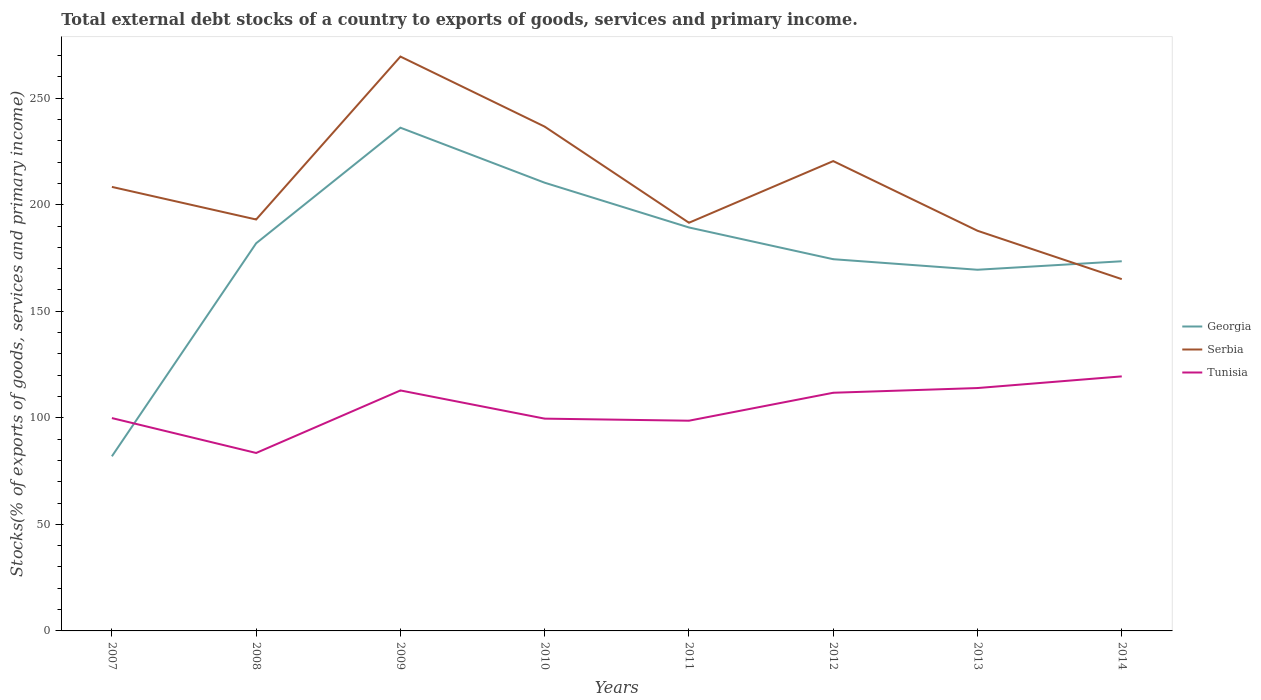How many different coloured lines are there?
Provide a succinct answer. 3. Across all years, what is the maximum total debt stocks in Georgia?
Ensure brevity in your answer.  81.94. What is the total total debt stocks in Georgia in the graph?
Your answer should be compact. 12.43. What is the difference between the highest and the second highest total debt stocks in Tunisia?
Provide a short and direct response. 35.95. Is the total debt stocks in Georgia strictly greater than the total debt stocks in Tunisia over the years?
Keep it short and to the point. No. How many years are there in the graph?
Offer a very short reply. 8. What is the difference between two consecutive major ticks on the Y-axis?
Offer a terse response. 50. Are the values on the major ticks of Y-axis written in scientific E-notation?
Provide a succinct answer. No. Does the graph contain grids?
Your response must be concise. No. Where does the legend appear in the graph?
Your answer should be very brief. Center right. What is the title of the graph?
Your response must be concise. Total external debt stocks of a country to exports of goods, services and primary income. Does "Djibouti" appear as one of the legend labels in the graph?
Give a very brief answer. No. What is the label or title of the X-axis?
Offer a very short reply. Years. What is the label or title of the Y-axis?
Offer a very short reply. Stocks(% of exports of goods, services and primary income). What is the Stocks(% of exports of goods, services and primary income) of Georgia in 2007?
Provide a short and direct response. 81.94. What is the Stocks(% of exports of goods, services and primary income) in Serbia in 2007?
Ensure brevity in your answer.  208.38. What is the Stocks(% of exports of goods, services and primary income) in Tunisia in 2007?
Offer a very short reply. 99.89. What is the Stocks(% of exports of goods, services and primary income) in Georgia in 2008?
Give a very brief answer. 181.93. What is the Stocks(% of exports of goods, services and primary income) of Serbia in 2008?
Offer a very short reply. 193.09. What is the Stocks(% of exports of goods, services and primary income) of Tunisia in 2008?
Ensure brevity in your answer.  83.51. What is the Stocks(% of exports of goods, services and primary income) of Georgia in 2009?
Offer a terse response. 236.17. What is the Stocks(% of exports of goods, services and primary income) of Serbia in 2009?
Provide a short and direct response. 269.55. What is the Stocks(% of exports of goods, services and primary income) in Tunisia in 2009?
Ensure brevity in your answer.  112.86. What is the Stocks(% of exports of goods, services and primary income) of Georgia in 2010?
Your answer should be compact. 210.35. What is the Stocks(% of exports of goods, services and primary income) of Serbia in 2010?
Offer a terse response. 236.67. What is the Stocks(% of exports of goods, services and primary income) of Tunisia in 2010?
Your answer should be compact. 99.63. What is the Stocks(% of exports of goods, services and primary income) of Georgia in 2011?
Your answer should be very brief. 189.34. What is the Stocks(% of exports of goods, services and primary income) in Serbia in 2011?
Your response must be concise. 191.56. What is the Stocks(% of exports of goods, services and primary income) of Tunisia in 2011?
Offer a terse response. 98.66. What is the Stocks(% of exports of goods, services and primary income) of Georgia in 2012?
Your response must be concise. 174.45. What is the Stocks(% of exports of goods, services and primary income) of Serbia in 2012?
Offer a very short reply. 220.5. What is the Stocks(% of exports of goods, services and primary income) of Tunisia in 2012?
Offer a very short reply. 111.77. What is the Stocks(% of exports of goods, services and primary income) in Georgia in 2013?
Your response must be concise. 169.5. What is the Stocks(% of exports of goods, services and primary income) in Serbia in 2013?
Make the answer very short. 187.8. What is the Stocks(% of exports of goods, services and primary income) in Tunisia in 2013?
Offer a very short reply. 113.98. What is the Stocks(% of exports of goods, services and primary income) in Georgia in 2014?
Make the answer very short. 173.49. What is the Stocks(% of exports of goods, services and primary income) in Serbia in 2014?
Keep it short and to the point. 165.09. What is the Stocks(% of exports of goods, services and primary income) of Tunisia in 2014?
Provide a succinct answer. 119.46. Across all years, what is the maximum Stocks(% of exports of goods, services and primary income) of Georgia?
Make the answer very short. 236.17. Across all years, what is the maximum Stocks(% of exports of goods, services and primary income) of Serbia?
Your answer should be very brief. 269.55. Across all years, what is the maximum Stocks(% of exports of goods, services and primary income) of Tunisia?
Give a very brief answer. 119.46. Across all years, what is the minimum Stocks(% of exports of goods, services and primary income) in Georgia?
Your answer should be very brief. 81.94. Across all years, what is the minimum Stocks(% of exports of goods, services and primary income) in Serbia?
Offer a very short reply. 165.09. Across all years, what is the minimum Stocks(% of exports of goods, services and primary income) in Tunisia?
Your answer should be very brief. 83.51. What is the total Stocks(% of exports of goods, services and primary income) in Georgia in the graph?
Provide a succinct answer. 1417.17. What is the total Stocks(% of exports of goods, services and primary income) of Serbia in the graph?
Your answer should be compact. 1672.65. What is the total Stocks(% of exports of goods, services and primary income) in Tunisia in the graph?
Make the answer very short. 839.78. What is the difference between the Stocks(% of exports of goods, services and primary income) in Georgia in 2007 and that in 2008?
Your answer should be compact. -99.99. What is the difference between the Stocks(% of exports of goods, services and primary income) in Serbia in 2007 and that in 2008?
Offer a terse response. 15.29. What is the difference between the Stocks(% of exports of goods, services and primary income) in Tunisia in 2007 and that in 2008?
Keep it short and to the point. 16.38. What is the difference between the Stocks(% of exports of goods, services and primary income) of Georgia in 2007 and that in 2009?
Offer a very short reply. -154.23. What is the difference between the Stocks(% of exports of goods, services and primary income) of Serbia in 2007 and that in 2009?
Offer a very short reply. -61.17. What is the difference between the Stocks(% of exports of goods, services and primary income) of Tunisia in 2007 and that in 2009?
Ensure brevity in your answer.  -12.97. What is the difference between the Stocks(% of exports of goods, services and primary income) of Georgia in 2007 and that in 2010?
Provide a succinct answer. -128.41. What is the difference between the Stocks(% of exports of goods, services and primary income) in Serbia in 2007 and that in 2010?
Ensure brevity in your answer.  -28.29. What is the difference between the Stocks(% of exports of goods, services and primary income) of Tunisia in 2007 and that in 2010?
Give a very brief answer. 0.26. What is the difference between the Stocks(% of exports of goods, services and primary income) in Georgia in 2007 and that in 2011?
Ensure brevity in your answer.  -107.4. What is the difference between the Stocks(% of exports of goods, services and primary income) in Serbia in 2007 and that in 2011?
Keep it short and to the point. 16.82. What is the difference between the Stocks(% of exports of goods, services and primary income) of Tunisia in 2007 and that in 2011?
Offer a very short reply. 1.24. What is the difference between the Stocks(% of exports of goods, services and primary income) of Georgia in 2007 and that in 2012?
Offer a very short reply. -92.51. What is the difference between the Stocks(% of exports of goods, services and primary income) of Serbia in 2007 and that in 2012?
Ensure brevity in your answer.  -12.11. What is the difference between the Stocks(% of exports of goods, services and primary income) of Tunisia in 2007 and that in 2012?
Your answer should be compact. -11.88. What is the difference between the Stocks(% of exports of goods, services and primary income) of Georgia in 2007 and that in 2013?
Give a very brief answer. -87.56. What is the difference between the Stocks(% of exports of goods, services and primary income) in Serbia in 2007 and that in 2013?
Provide a short and direct response. 20.59. What is the difference between the Stocks(% of exports of goods, services and primary income) in Tunisia in 2007 and that in 2013?
Your response must be concise. -14.09. What is the difference between the Stocks(% of exports of goods, services and primary income) of Georgia in 2007 and that in 2014?
Keep it short and to the point. -91.55. What is the difference between the Stocks(% of exports of goods, services and primary income) of Serbia in 2007 and that in 2014?
Your response must be concise. 43.29. What is the difference between the Stocks(% of exports of goods, services and primary income) in Tunisia in 2007 and that in 2014?
Ensure brevity in your answer.  -19.57. What is the difference between the Stocks(% of exports of goods, services and primary income) of Georgia in 2008 and that in 2009?
Ensure brevity in your answer.  -54.24. What is the difference between the Stocks(% of exports of goods, services and primary income) in Serbia in 2008 and that in 2009?
Provide a succinct answer. -76.47. What is the difference between the Stocks(% of exports of goods, services and primary income) of Tunisia in 2008 and that in 2009?
Your answer should be compact. -29.34. What is the difference between the Stocks(% of exports of goods, services and primary income) in Georgia in 2008 and that in 2010?
Provide a succinct answer. -28.42. What is the difference between the Stocks(% of exports of goods, services and primary income) of Serbia in 2008 and that in 2010?
Keep it short and to the point. -43.58. What is the difference between the Stocks(% of exports of goods, services and primary income) in Tunisia in 2008 and that in 2010?
Give a very brief answer. -16.11. What is the difference between the Stocks(% of exports of goods, services and primary income) in Georgia in 2008 and that in 2011?
Provide a succinct answer. -7.41. What is the difference between the Stocks(% of exports of goods, services and primary income) of Serbia in 2008 and that in 2011?
Ensure brevity in your answer.  1.53. What is the difference between the Stocks(% of exports of goods, services and primary income) of Tunisia in 2008 and that in 2011?
Provide a short and direct response. -15.14. What is the difference between the Stocks(% of exports of goods, services and primary income) of Georgia in 2008 and that in 2012?
Make the answer very short. 7.48. What is the difference between the Stocks(% of exports of goods, services and primary income) in Serbia in 2008 and that in 2012?
Offer a terse response. -27.41. What is the difference between the Stocks(% of exports of goods, services and primary income) of Tunisia in 2008 and that in 2012?
Give a very brief answer. -28.26. What is the difference between the Stocks(% of exports of goods, services and primary income) of Georgia in 2008 and that in 2013?
Ensure brevity in your answer.  12.43. What is the difference between the Stocks(% of exports of goods, services and primary income) in Serbia in 2008 and that in 2013?
Offer a terse response. 5.29. What is the difference between the Stocks(% of exports of goods, services and primary income) of Tunisia in 2008 and that in 2013?
Offer a terse response. -30.47. What is the difference between the Stocks(% of exports of goods, services and primary income) in Georgia in 2008 and that in 2014?
Ensure brevity in your answer.  8.44. What is the difference between the Stocks(% of exports of goods, services and primary income) of Serbia in 2008 and that in 2014?
Give a very brief answer. 27.99. What is the difference between the Stocks(% of exports of goods, services and primary income) of Tunisia in 2008 and that in 2014?
Give a very brief answer. -35.95. What is the difference between the Stocks(% of exports of goods, services and primary income) in Georgia in 2009 and that in 2010?
Offer a terse response. 25.82. What is the difference between the Stocks(% of exports of goods, services and primary income) in Serbia in 2009 and that in 2010?
Offer a very short reply. 32.89. What is the difference between the Stocks(% of exports of goods, services and primary income) of Tunisia in 2009 and that in 2010?
Provide a short and direct response. 13.23. What is the difference between the Stocks(% of exports of goods, services and primary income) of Georgia in 2009 and that in 2011?
Make the answer very short. 46.83. What is the difference between the Stocks(% of exports of goods, services and primary income) in Serbia in 2009 and that in 2011?
Give a very brief answer. 77.99. What is the difference between the Stocks(% of exports of goods, services and primary income) in Tunisia in 2009 and that in 2011?
Give a very brief answer. 14.2. What is the difference between the Stocks(% of exports of goods, services and primary income) in Georgia in 2009 and that in 2012?
Your answer should be very brief. 61.72. What is the difference between the Stocks(% of exports of goods, services and primary income) in Serbia in 2009 and that in 2012?
Provide a succinct answer. 49.06. What is the difference between the Stocks(% of exports of goods, services and primary income) of Tunisia in 2009 and that in 2012?
Keep it short and to the point. 1.09. What is the difference between the Stocks(% of exports of goods, services and primary income) in Georgia in 2009 and that in 2013?
Offer a terse response. 66.67. What is the difference between the Stocks(% of exports of goods, services and primary income) of Serbia in 2009 and that in 2013?
Your answer should be compact. 81.76. What is the difference between the Stocks(% of exports of goods, services and primary income) in Tunisia in 2009 and that in 2013?
Offer a terse response. -1.13. What is the difference between the Stocks(% of exports of goods, services and primary income) in Georgia in 2009 and that in 2014?
Offer a very short reply. 62.68. What is the difference between the Stocks(% of exports of goods, services and primary income) in Serbia in 2009 and that in 2014?
Make the answer very short. 104.46. What is the difference between the Stocks(% of exports of goods, services and primary income) in Tunisia in 2009 and that in 2014?
Provide a succinct answer. -6.6. What is the difference between the Stocks(% of exports of goods, services and primary income) in Georgia in 2010 and that in 2011?
Offer a very short reply. 21.01. What is the difference between the Stocks(% of exports of goods, services and primary income) in Serbia in 2010 and that in 2011?
Provide a succinct answer. 45.11. What is the difference between the Stocks(% of exports of goods, services and primary income) in Tunisia in 2010 and that in 2011?
Give a very brief answer. 0.97. What is the difference between the Stocks(% of exports of goods, services and primary income) of Georgia in 2010 and that in 2012?
Keep it short and to the point. 35.9. What is the difference between the Stocks(% of exports of goods, services and primary income) of Serbia in 2010 and that in 2012?
Keep it short and to the point. 16.17. What is the difference between the Stocks(% of exports of goods, services and primary income) in Tunisia in 2010 and that in 2012?
Your response must be concise. -12.15. What is the difference between the Stocks(% of exports of goods, services and primary income) in Georgia in 2010 and that in 2013?
Ensure brevity in your answer.  40.85. What is the difference between the Stocks(% of exports of goods, services and primary income) in Serbia in 2010 and that in 2013?
Keep it short and to the point. 48.87. What is the difference between the Stocks(% of exports of goods, services and primary income) in Tunisia in 2010 and that in 2013?
Make the answer very short. -14.36. What is the difference between the Stocks(% of exports of goods, services and primary income) in Georgia in 2010 and that in 2014?
Ensure brevity in your answer.  36.86. What is the difference between the Stocks(% of exports of goods, services and primary income) of Serbia in 2010 and that in 2014?
Give a very brief answer. 71.57. What is the difference between the Stocks(% of exports of goods, services and primary income) of Tunisia in 2010 and that in 2014?
Provide a short and direct response. -19.84. What is the difference between the Stocks(% of exports of goods, services and primary income) of Georgia in 2011 and that in 2012?
Give a very brief answer. 14.89. What is the difference between the Stocks(% of exports of goods, services and primary income) in Serbia in 2011 and that in 2012?
Provide a succinct answer. -28.94. What is the difference between the Stocks(% of exports of goods, services and primary income) of Tunisia in 2011 and that in 2012?
Provide a succinct answer. -13.12. What is the difference between the Stocks(% of exports of goods, services and primary income) in Georgia in 2011 and that in 2013?
Your answer should be compact. 19.84. What is the difference between the Stocks(% of exports of goods, services and primary income) of Serbia in 2011 and that in 2013?
Provide a succinct answer. 3.76. What is the difference between the Stocks(% of exports of goods, services and primary income) of Tunisia in 2011 and that in 2013?
Your answer should be compact. -15.33. What is the difference between the Stocks(% of exports of goods, services and primary income) of Georgia in 2011 and that in 2014?
Ensure brevity in your answer.  15.85. What is the difference between the Stocks(% of exports of goods, services and primary income) in Serbia in 2011 and that in 2014?
Make the answer very short. 26.47. What is the difference between the Stocks(% of exports of goods, services and primary income) in Tunisia in 2011 and that in 2014?
Provide a succinct answer. -20.81. What is the difference between the Stocks(% of exports of goods, services and primary income) of Georgia in 2012 and that in 2013?
Provide a short and direct response. 4.95. What is the difference between the Stocks(% of exports of goods, services and primary income) of Serbia in 2012 and that in 2013?
Keep it short and to the point. 32.7. What is the difference between the Stocks(% of exports of goods, services and primary income) in Tunisia in 2012 and that in 2013?
Your answer should be compact. -2.21. What is the difference between the Stocks(% of exports of goods, services and primary income) in Georgia in 2012 and that in 2014?
Offer a very short reply. 0.96. What is the difference between the Stocks(% of exports of goods, services and primary income) of Serbia in 2012 and that in 2014?
Offer a very short reply. 55.4. What is the difference between the Stocks(% of exports of goods, services and primary income) of Tunisia in 2012 and that in 2014?
Your response must be concise. -7.69. What is the difference between the Stocks(% of exports of goods, services and primary income) in Georgia in 2013 and that in 2014?
Provide a short and direct response. -3.99. What is the difference between the Stocks(% of exports of goods, services and primary income) in Serbia in 2013 and that in 2014?
Offer a terse response. 22.7. What is the difference between the Stocks(% of exports of goods, services and primary income) of Tunisia in 2013 and that in 2014?
Make the answer very short. -5.48. What is the difference between the Stocks(% of exports of goods, services and primary income) in Georgia in 2007 and the Stocks(% of exports of goods, services and primary income) in Serbia in 2008?
Provide a short and direct response. -111.15. What is the difference between the Stocks(% of exports of goods, services and primary income) in Georgia in 2007 and the Stocks(% of exports of goods, services and primary income) in Tunisia in 2008?
Provide a short and direct response. -1.57. What is the difference between the Stocks(% of exports of goods, services and primary income) in Serbia in 2007 and the Stocks(% of exports of goods, services and primary income) in Tunisia in 2008?
Offer a very short reply. 124.87. What is the difference between the Stocks(% of exports of goods, services and primary income) in Georgia in 2007 and the Stocks(% of exports of goods, services and primary income) in Serbia in 2009?
Your answer should be very brief. -187.61. What is the difference between the Stocks(% of exports of goods, services and primary income) in Georgia in 2007 and the Stocks(% of exports of goods, services and primary income) in Tunisia in 2009?
Offer a very short reply. -30.92. What is the difference between the Stocks(% of exports of goods, services and primary income) of Serbia in 2007 and the Stocks(% of exports of goods, services and primary income) of Tunisia in 2009?
Keep it short and to the point. 95.52. What is the difference between the Stocks(% of exports of goods, services and primary income) of Georgia in 2007 and the Stocks(% of exports of goods, services and primary income) of Serbia in 2010?
Provide a short and direct response. -154.73. What is the difference between the Stocks(% of exports of goods, services and primary income) in Georgia in 2007 and the Stocks(% of exports of goods, services and primary income) in Tunisia in 2010?
Ensure brevity in your answer.  -17.69. What is the difference between the Stocks(% of exports of goods, services and primary income) of Serbia in 2007 and the Stocks(% of exports of goods, services and primary income) of Tunisia in 2010?
Your response must be concise. 108.76. What is the difference between the Stocks(% of exports of goods, services and primary income) in Georgia in 2007 and the Stocks(% of exports of goods, services and primary income) in Serbia in 2011?
Provide a succinct answer. -109.62. What is the difference between the Stocks(% of exports of goods, services and primary income) of Georgia in 2007 and the Stocks(% of exports of goods, services and primary income) of Tunisia in 2011?
Offer a terse response. -16.71. What is the difference between the Stocks(% of exports of goods, services and primary income) of Serbia in 2007 and the Stocks(% of exports of goods, services and primary income) of Tunisia in 2011?
Make the answer very short. 109.73. What is the difference between the Stocks(% of exports of goods, services and primary income) of Georgia in 2007 and the Stocks(% of exports of goods, services and primary income) of Serbia in 2012?
Your response must be concise. -138.55. What is the difference between the Stocks(% of exports of goods, services and primary income) of Georgia in 2007 and the Stocks(% of exports of goods, services and primary income) of Tunisia in 2012?
Your answer should be compact. -29.83. What is the difference between the Stocks(% of exports of goods, services and primary income) of Serbia in 2007 and the Stocks(% of exports of goods, services and primary income) of Tunisia in 2012?
Give a very brief answer. 96.61. What is the difference between the Stocks(% of exports of goods, services and primary income) of Georgia in 2007 and the Stocks(% of exports of goods, services and primary income) of Serbia in 2013?
Make the answer very short. -105.86. What is the difference between the Stocks(% of exports of goods, services and primary income) in Georgia in 2007 and the Stocks(% of exports of goods, services and primary income) in Tunisia in 2013?
Provide a succinct answer. -32.04. What is the difference between the Stocks(% of exports of goods, services and primary income) in Serbia in 2007 and the Stocks(% of exports of goods, services and primary income) in Tunisia in 2013?
Your response must be concise. 94.4. What is the difference between the Stocks(% of exports of goods, services and primary income) in Georgia in 2007 and the Stocks(% of exports of goods, services and primary income) in Serbia in 2014?
Offer a terse response. -83.15. What is the difference between the Stocks(% of exports of goods, services and primary income) of Georgia in 2007 and the Stocks(% of exports of goods, services and primary income) of Tunisia in 2014?
Your response must be concise. -37.52. What is the difference between the Stocks(% of exports of goods, services and primary income) in Serbia in 2007 and the Stocks(% of exports of goods, services and primary income) in Tunisia in 2014?
Ensure brevity in your answer.  88.92. What is the difference between the Stocks(% of exports of goods, services and primary income) in Georgia in 2008 and the Stocks(% of exports of goods, services and primary income) in Serbia in 2009?
Provide a short and direct response. -87.63. What is the difference between the Stocks(% of exports of goods, services and primary income) of Georgia in 2008 and the Stocks(% of exports of goods, services and primary income) of Tunisia in 2009?
Offer a terse response. 69.07. What is the difference between the Stocks(% of exports of goods, services and primary income) of Serbia in 2008 and the Stocks(% of exports of goods, services and primary income) of Tunisia in 2009?
Ensure brevity in your answer.  80.23. What is the difference between the Stocks(% of exports of goods, services and primary income) of Georgia in 2008 and the Stocks(% of exports of goods, services and primary income) of Serbia in 2010?
Offer a very short reply. -54.74. What is the difference between the Stocks(% of exports of goods, services and primary income) in Georgia in 2008 and the Stocks(% of exports of goods, services and primary income) in Tunisia in 2010?
Your answer should be compact. 82.3. What is the difference between the Stocks(% of exports of goods, services and primary income) in Serbia in 2008 and the Stocks(% of exports of goods, services and primary income) in Tunisia in 2010?
Offer a very short reply. 93.46. What is the difference between the Stocks(% of exports of goods, services and primary income) in Georgia in 2008 and the Stocks(% of exports of goods, services and primary income) in Serbia in 2011?
Give a very brief answer. -9.63. What is the difference between the Stocks(% of exports of goods, services and primary income) in Georgia in 2008 and the Stocks(% of exports of goods, services and primary income) in Tunisia in 2011?
Your answer should be compact. 83.27. What is the difference between the Stocks(% of exports of goods, services and primary income) in Serbia in 2008 and the Stocks(% of exports of goods, services and primary income) in Tunisia in 2011?
Make the answer very short. 94.43. What is the difference between the Stocks(% of exports of goods, services and primary income) in Georgia in 2008 and the Stocks(% of exports of goods, services and primary income) in Serbia in 2012?
Give a very brief answer. -38.57. What is the difference between the Stocks(% of exports of goods, services and primary income) of Georgia in 2008 and the Stocks(% of exports of goods, services and primary income) of Tunisia in 2012?
Offer a very short reply. 70.15. What is the difference between the Stocks(% of exports of goods, services and primary income) of Serbia in 2008 and the Stocks(% of exports of goods, services and primary income) of Tunisia in 2012?
Give a very brief answer. 81.31. What is the difference between the Stocks(% of exports of goods, services and primary income) of Georgia in 2008 and the Stocks(% of exports of goods, services and primary income) of Serbia in 2013?
Ensure brevity in your answer.  -5.87. What is the difference between the Stocks(% of exports of goods, services and primary income) in Georgia in 2008 and the Stocks(% of exports of goods, services and primary income) in Tunisia in 2013?
Your response must be concise. 67.94. What is the difference between the Stocks(% of exports of goods, services and primary income) in Serbia in 2008 and the Stocks(% of exports of goods, services and primary income) in Tunisia in 2013?
Your response must be concise. 79.1. What is the difference between the Stocks(% of exports of goods, services and primary income) in Georgia in 2008 and the Stocks(% of exports of goods, services and primary income) in Serbia in 2014?
Your answer should be compact. 16.83. What is the difference between the Stocks(% of exports of goods, services and primary income) of Georgia in 2008 and the Stocks(% of exports of goods, services and primary income) of Tunisia in 2014?
Offer a very short reply. 62.46. What is the difference between the Stocks(% of exports of goods, services and primary income) of Serbia in 2008 and the Stocks(% of exports of goods, services and primary income) of Tunisia in 2014?
Your answer should be compact. 73.62. What is the difference between the Stocks(% of exports of goods, services and primary income) of Georgia in 2009 and the Stocks(% of exports of goods, services and primary income) of Serbia in 2010?
Ensure brevity in your answer.  -0.5. What is the difference between the Stocks(% of exports of goods, services and primary income) of Georgia in 2009 and the Stocks(% of exports of goods, services and primary income) of Tunisia in 2010?
Keep it short and to the point. 136.54. What is the difference between the Stocks(% of exports of goods, services and primary income) in Serbia in 2009 and the Stocks(% of exports of goods, services and primary income) in Tunisia in 2010?
Your response must be concise. 169.93. What is the difference between the Stocks(% of exports of goods, services and primary income) in Georgia in 2009 and the Stocks(% of exports of goods, services and primary income) in Serbia in 2011?
Give a very brief answer. 44.61. What is the difference between the Stocks(% of exports of goods, services and primary income) of Georgia in 2009 and the Stocks(% of exports of goods, services and primary income) of Tunisia in 2011?
Keep it short and to the point. 137.51. What is the difference between the Stocks(% of exports of goods, services and primary income) of Serbia in 2009 and the Stocks(% of exports of goods, services and primary income) of Tunisia in 2011?
Your answer should be compact. 170.9. What is the difference between the Stocks(% of exports of goods, services and primary income) of Georgia in 2009 and the Stocks(% of exports of goods, services and primary income) of Serbia in 2012?
Your answer should be very brief. 15.67. What is the difference between the Stocks(% of exports of goods, services and primary income) of Georgia in 2009 and the Stocks(% of exports of goods, services and primary income) of Tunisia in 2012?
Your answer should be compact. 124.39. What is the difference between the Stocks(% of exports of goods, services and primary income) of Serbia in 2009 and the Stocks(% of exports of goods, services and primary income) of Tunisia in 2012?
Provide a succinct answer. 157.78. What is the difference between the Stocks(% of exports of goods, services and primary income) of Georgia in 2009 and the Stocks(% of exports of goods, services and primary income) of Serbia in 2013?
Offer a terse response. 48.37. What is the difference between the Stocks(% of exports of goods, services and primary income) of Georgia in 2009 and the Stocks(% of exports of goods, services and primary income) of Tunisia in 2013?
Offer a very short reply. 122.18. What is the difference between the Stocks(% of exports of goods, services and primary income) in Serbia in 2009 and the Stocks(% of exports of goods, services and primary income) in Tunisia in 2013?
Provide a succinct answer. 155.57. What is the difference between the Stocks(% of exports of goods, services and primary income) in Georgia in 2009 and the Stocks(% of exports of goods, services and primary income) in Serbia in 2014?
Give a very brief answer. 71.07. What is the difference between the Stocks(% of exports of goods, services and primary income) of Georgia in 2009 and the Stocks(% of exports of goods, services and primary income) of Tunisia in 2014?
Your answer should be very brief. 116.71. What is the difference between the Stocks(% of exports of goods, services and primary income) of Serbia in 2009 and the Stocks(% of exports of goods, services and primary income) of Tunisia in 2014?
Offer a very short reply. 150.09. What is the difference between the Stocks(% of exports of goods, services and primary income) in Georgia in 2010 and the Stocks(% of exports of goods, services and primary income) in Serbia in 2011?
Ensure brevity in your answer.  18.79. What is the difference between the Stocks(% of exports of goods, services and primary income) in Georgia in 2010 and the Stocks(% of exports of goods, services and primary income) in Tunisia in 2011?
Offer a very short reply. 111.69. What is the difference between the Stocks(% of exports of goods, services and primary income) in Serbia in 2010 and the Stocks(% of exports of goods, services and primary income) in Tunisia in 2011?
Keep it short and to the point. 138.01. What is the difference between the Stocks(% of exports of goods, services and primary income) of Georgia in 2010 and the Stocks(% of exports of goods, services and primary income) of Serbia in 2012?
Ensure brevity in your answer.  -10.15. What is the difference between the Stocks(% of exports of goods, services and primary income) in Georgia in 2010 and the Stocks(% of exports of goods, services and primary income) in Tunisia in 2012?
Provide a succinct answer. 98.58. What is the difference between the Stocks(% of exports of goods, services and primary income) of Serbia in 2010 and the Stocks(% of exports of goods, services and primary income) of Tunisia in 2012?
Offer a very short reply. 124.89. What is the difference between the Stocks(% of exports of goods, services and primary income) of Georgia in 2010 and the Stocks(% of exports of goods, services and primary income) of Serbia in 2013?
Give a very brief answer. 22.55. What is the difference between the Stocks(% of exports of goods, services and primary income) of Georgia in 2010 and the Stocks(% of exports of goods, services and primary income) of Tunisia in 2013?
Provide a succinct answer. 96.36. What is the difference between the Stocks(% of exports of goods, services and primary income) in Serbia in 2010 and the Stocks(% of exports of goods, services and primary income) in Tunisia in 2013?
Ensure brevity in your answer.  122.68. What is the difference between the Stocks(% of exports of goods, services and primary income) in Georgia in 2010 and the Stocks(% of exports of goods, services and primary income) in Serbia in 2014?
Ensure brevity in your answer.  45.25. What is the difference between the Stocks(% of exports of goods, services and primary income) in Georgia in 2010 and the Stocks(% of exports of goods, services and primary income) in Tunisia in 2014?
Keep it short and to the point. 90.89. What is the difference between the Stocks(% of exports of goods, services and primary income) in Serbia in 2010 and the Stocks(% of exports of goods, services and primary income) in Tunisia in 2014?
Your answer should be compact. 117.2. What is the difference between the Stocks(% of exports of goods, services and primary income) of Georgia in 2011 and the Stocks(% of exports of goods, services and primary income) of Serbia in 2012?
Provide a succinct answer. -31.15. What is the difference between the Stocks(% of exports of goods, services and primary income) of Georgia in 2011 and the Stocks(% of exports of goods, services and primary income) of Tunisia in 2012?
Provide a succinct answer. 77.57. What is the difference between the Stocks(% of exports of goods, services and primary income) in Serbia in 2011 and the Stocks(% of exports of goods, services and primary income) in Tunisia in 2012?
Your answer should be very brief. 79.79. What is the difference between the Stocks(% of exports of goods, services and primary income) of Georgia in 2011 and the Stocks(% of exports of goods, services and primary income) of Serbia in 2013?
Provide a short and direct response. 1.54. What is the difference between the Stocks(% of exports of goods, services and primary income) of Georgia in 2011 and the Stocks(% of exports of goods, services and primary income) of Tunisia in 2013?
Ensure brevity in your answer.  75.36. What is the difference between the Stocks(% of exports of goods, services and primary income) in Serbia in 2011 and the Stocks(% of exports of goods, services and primary income) in Tunisia in 2013?
Provide a short and direct response. 77.58. What is the difference between the Stocks(% of exports of goods, services and primary income) in Georgia in 2011 and the Stocks(% of exports of goods, services and primary income) in Serbia in 2014?
Offer a very short reply. 24.25. What is the difference between the Stocks(% of exports of goods, services and primary income) of Georgia in 2011 and the Stocks(% of exports of goods, services and primary income) of Tunisia in 2014?
Make the answer very short. 69.88. What is the difference between the Stocks(% of exports of goods, services and primary income) of Serbia in 2011 and the Stocks(% of exports of goods, services and primary income) of Tunisia in 2014?
Offer a terse response. 72.1. What is the difference between the Stocks(% of exports of goods, services and primary income) in Georgia in 2012 and the Stocks(% of exports of goods, services and primary income) in Serbia in 2013?
Your response must be concise. -13.35. What is the difference between the Stocks(% of exports of goods, services and primary income) of Georgia in 2012 and the Stocks(% of exports of goods, services and primary income) of Tunisia in 2013?
Ensure brevity in your answer.  60.47. What is the difference between the Stocks(% of exports of goods, services and primary income) in Serbia in 2012 and the Stocks(% of exports of goods, services and primary income) in Tunisia in 2013?
Make the answer very short. 106.51. What is the difference between the Stocks(% of exports of goods, services and primary income) of Georgia in 2012 and the Stocks(% of exports of goods, services and primary income) of Serbia in 2014?
Provide a succinct answer. 9.36. What is the difference between the Stocks(% of exports of goods, services and primary income) in Georgia in 2012 and the Stocks(% of exports of goods, services and primary income) in Tunisia in 2014?
Keep it short and to the point. 54.99. What is the difference between the Stocks(% of exports of goods, services and primary income) of Serbia in 2012 and the Stocks(% of exports of goods, services and primary income) of Tunisia in 2014?
Offer a terse response. 101.03. What is the difference between the Stocks(% of exports of goods, services and primary income) in Georgia in 2013 and the Stocks(% of exports of goods, services and primary income) in Serbia in 2014?
Keep it short and to the point. 4.41. What is the difference between the Stocks(% of exports of goods, services and primary income) in Georgia in 2013 and the Stocks(% of exports of goods, services and primary income) in Tunisia in 2014?
Provide a short and direct response. 50.04. What is the difference between the Stocks(% of exports of goods, services and primary income) of Serbia in 2013 and the Stocks(% of exports of goods, services and primary income) of Tunisia in 2014?
Offer a terse response. 68.33. What is the average Stocks(% of exports of goods, services and primary income) in Georgia per year?
Offer a terse response. 177.15. What is the average Stocks(% of exports of goods, services and primary income) of Serbia per year?
Give a very brief answer. 209.08. What is the average Stocks(% of exports of goods, services and primary income) of Tunisia per year?
Give a very brief answer. 104.97. In the year 2007, what is the difference between the Stocks(% of exports of goods, services and primary income) of Georgia and Stocks(% of exports of goods, services and primary income) of Serbia?
Your answer should be very brief. -126.44. In the year 2007, what is the difference between the Stocks(% of exports of goods, services and primary income) in Georgia and Stocks(% of exports of goods, services and primary income) in Tunisia?
Offer a very short reply. -17.95. In the year 2007, what is the difference between the Stocks(% of exports of goods, services and primary income) in Serbia and Stocks(% of exports of goods, services and primary income) in Tunisia?
Your answer should be compact. 108.49. In the year 2008, what is the difference between the Stocks(% of exports of goods, services and primary income) in Georgia and Stocks(% of exports of goods, services and primary income) in Serbia?
Provide a succinct answer. -11.16. In the year 2008, what is the difference between the Stocks(% of exports of goods, services and primary income) in Georgia and Stocks(% of exports of goods, services and primary income) in Tunisia?
Make the answer very short. 98.41. In the year 2008, what is the difference between the Stocks(% of exports of goods, services and primary income) in Serbia and Stocks(% of exports of goods, services and primary income) in Tunisia?
Your response must be concise. 109.57. In the year 2009, what is the difference between the Stocks(% of exports of goods, services and primary income) in Georgia and Stocks(% of exports of goods, services and primary income) in Serbia?
Keep it short and to the point. -33.39. In the year 2009, what is the difference between the Stocks(% of exports of goods, services and primary income) of Georgia and Stocks(% of exports of goods, services and primary income) of Tunisia?
Your answer should be compact. 123.31. In the year 2009, what is the difference between the Stocks(% of exports of goods, services and primary income) of Serbia and Stocks(% of exports of goods, services and primary income) of Tunisia?
Ensure brevity in your answer.  156.69. In the year 2010, what is the difference between the Stocks(% of exports of goods, services and primary income) in Georgia and Stocks(% of exports of goods, services and primary income) in Serbia?
Ensure brevity in your answer.  -26.32. In the year 2010, what is the difference between the Stocks(% of exports of goods, services and primary income) in Georgia and Stocks(% of exports of goods, services and primary income) in Tunisia?
Provide a succinct answer. 110.72. In the year 2010, what is the difference between the Stocks(% of exports of goods, services and primary income) of Serbia and Stocks(% of exports of goods, services and primary income) of Tunisia?
Give a very brief answer. 137.04. In the year 2011, what is the difference between the Stocks(% of exports of goods, services and primary income) of Georgia and Stocks(% of exports of goods, services and primary income) of Serbia?
Your answer should be very brief. -2.22. In the year 2011, what is the difference between the Stocks(% of exports of goods, services and primary income) of Georgia and Stocks(% of exports of goods, services and primary income) of Tunisia?
Offer a terse response. 90.69. In the year 2011, what is the difference between the Stocks(% of exports of goods, services and primary income) of Serbia and Stocks(% of exports of goods, services and primary income) of Tunisia?
Make the answer very short. 92.9. In the year 2012, what is the difference between the Stocks(% of exports of goods, services and primary income) of Georgia and Stocks(% of exports of goods, services and primary income) of Serbia?
Offer a terse response. -46.05. In the year 2012, what is the difference between the Stocks(% of exports of goods, services and primary income) in Georgia and Stocks(% of exports of goods, services and primary income) in Tunisia?
Your answer should be compact. 62.68. In the year 2012, what is the difference between the Stocks(% of exports of goods, services and primary income) in Serbia and Stocks(% of exports of goods, services and primary income) in Tunisia?
Your response must be concise. 108.72. In the year 2013, what is the difference between the Stocks(% of exports of goods, services and primary income) in Georgia and Stocks(% of exports of goods, services and primary income) in Serbia?
Ensure brevity in your answer.  -18.3. In the year 2013, what is the difference between the Stocks(% of exports of goods, services and primary income) of Georgia and Stocks(% of exports of goods, services and primary income) of Tunisia?
Provide a succinct answer. 55.51. In the year 2013, what is the difference between the Stocks(% of exports of goods, services and primary income) in Serbia and Stocks(% of exports of goods, services and primary income) in Tunisia?
Provide a short and direct response. 73.81. In the year 2014, what is the difference between the Stocks(% of exports of goods, services and primary income) in Georgia and Stocks(% of exports of goods, services and primary income) in Serbia?
Your answer should be compact. 8.39. In the year 2014, what is the difference between the Stocks(% of exports of goods, services and primary income) of Georgia and Stocks(% of exports of goods, services and primary income) of Tunisia?
Ensure brevity in your answer.  54.02. In the year 2014, what is the difference between the Stocks(% of exports of goods, services and primary income) in Serbia and Stocks(% of exports of goods, services and primary income) in Tunisia?
Offer a very short reply. 45.63. What is the ratio of the Stocks(% of exports of goods, services and primary income) in Georgia in 2007 to that in 2008?
Ensure brevity in your answer.  0.45. What is the ratio of the Stocks(% of exports of goods, services and primary income) in Serbia in 2007 to that in 2008?
Your answer should be very brief. 1.08. What is the ratio of the Stocks(% of exports of goods, services and primary income) in Tunisia in 2007 to that in 2008?
Keep it short and to the point. 1.2. What is the ratio of the Stocks(% of exports of goods, services and primary income) in Georgia in 2007 to that in 2009?
Keep it short and to the point. 0.35. What is the ratio of the Stocks(% of exports of goods, services and primary income) in Serbia in 2007 to that in 2009?
Your answer should be compact. 0.77. What is the ratio of the Stocks(% of exports of goods, services and primary income) of Tunisia in 2007 to that in 2009?
Make the answer very short. 0.89. What is the ratio of the Stocks(% of exports of goods, services and primary income) of Georgia in 2007 to that in 2010?
Your response must be concise. 0.39. What is the ratio of the Stocks(% of exports of goods, services and primary income) of Serbia in 2007 to that in 2010?
Make the answer very short. 0.88. What is the ratio of the Stocks(% of exports of goods, services and primary income) of Georgia in 2007 to that in 2011?
Provide a short and direct response. 0.43. What is the ratio of the Stocks(% of exports of goods, services and primary income) of Serbia in 2007 to that in 2011?
Keep it short and to the point. 1.09. What is the ratio of the Stocks(% of exports of goods, services and primary income) of Tunisia in 2007 to that in 2011?
Make the answer very short. 1.01. What is the ratio of the Stocks(% of exports of goods, services and primary income) of Georgia in 2007 to that in 2012?
Provide a short and direct response. 0.47. What is the ratio of the Stocks(% of exports of goods, services and primary income) of Serbia in 2007 to that in 2012?
Ensure brevity in your answer.  0.95. What is the ratio of the Stocks(% of exports of goods, services and primary income) of Tunisia in 2007 to that in 2012?
Give a very brief answer. 0.89. What is the ratio of the Stocks(% of exports of goods, services and primary income) in Georgia in 2007 to that in 2013?
Your answer should be compact. 0.48. What is the ratio of the Stocks(% of exports of goods, services and primary income) in Serbia in 2007 to that in 2013?
Your answer should be compact. 1.11. What is the ratio of the Stocks(% of exports of goods, services and primary income) in Tunisia in 2007 to that in 2013?
Keep it short and to the point. 0.88. What is the ratio of the Stocks(% of exports of goods, services and primary income) in Georgia in 2007 to that in 2014?
Your answer should be compact. 0.47. What is the ratio of the Stocks(% of exports of goods, services and primary income) of Serbia in 2007 to that in 2014?
Provide a succinct answer. 1.26. What is the ratio of the Stocks(% of exports of goods, services and primary income) of Tunisia in 2007 to that in 2014?
Provide a short and direct response. 0.84. What is the ratio of the Stocks(% of exports of goods, services and primary income) in Georgia in 2008 to that in 2009?
Offer a terse response. 0.77. What is the ratio of the Stocks(% of exports of goods, services and primary income) in Serbia in 2008 to that in 2009?
Make the answer very short. 0.72. What is the ratio of the Stocks(% of exports of goods, services and primary income) in Tunisia in 2008 to that in 2009?
Offer a very short reply. 0.74. What is the ratio of the Stocks(% of exports of goods, services and primary income) in Georgia in 2008 to that in 2010?
Provide a short and direct response. 0.86. What is the ratio of the Stocks(% of exports of goods, services and primary income) of Serbia in 2008 to that in 2010?
Your answer should be compact. 0.82. What is the ratio of the Stocks(% of exports of goods, services and primary income) of Tunisia in 2008 to that in 2010?
Give a very brief answer. 0.84. What is the ratio of the Stocks(% of exports of goods, services and primary income) of Georgia in 2008 to that in 2011?
Offer a terse response. 0.96. What is the ratio of the Stocks(% of exports of goods, services and primary income) of Tunisia in 2008 to that in 2011?
Offer a terse response. 0.85. What is the ratio of the Stocks(% of exports of goods, services and primary income) of Georgia in 2008 to that in 2012?
Provide a succinct answer. 1.04. What is the ratio of the Stocks(% of exports of goods, services and primary income) in Serbia in 2008 to that in 2012?
Offer a terse response. 0.88. What is the ratio of the Stocks(% of exports of goods, services and primary income) of Tunisia in 2008 to that in 2012?
Provide a succinct answer. 0.75. What is the ratio of the Stocks(% of exports of goods, services and primary income) of Georgia in 2008 to that in 2013?
Make the answer very short. 1.07. What is the ratio of the Stocks(% of exports of goods, services and primary income) in Serbia in 2008 to that in 2013?
Ensure brevity in your answer.  1.03. What is the ratio of the Stocks(% of exports of goods, services and primary income) of Tunisia in 2008 to that in 2013?
Make the answer very short. 0.73. What is the ratio of the Stocks(% of exports of goods, services and primary income) of Georgia in 2008 to that in 2014?
Keep it short and to the point. 1.05. What is the ratio of the Stocks(% of exports of goods, services and primary income) of Serbia in 2008 to that in 2014?
Offer a terse response. 1.17. What is the ratio of the Stocks(% of exports of goods, services and primary income) of Tunisia in 2008 to that in 2014?
Give a very brief answer. 0.7. What is the ratio of the Stocks(% of exports of goods, services and primary income) in Georgia in 2009 to that in 2010?
Your response must be concise. 1.12. What is the ratio of the Stocks(% of exports of goods, services and primary income) of Serbia in 2009 to that in 2010?
Your answer should be compact. 1.14. What is the ratio of the Stocks(% of exports of goods, services and primary income) of Tunisia in 2009 to that in 2010?
Provide a short and direct response. 1.13. What is the ratio of the Stocks(% of exports of goods, services and primary income) in Georgia in 2009 to that in 2011?
Keep it short and to the point. 1.25. What is the ratio of the Stocks(% of exports of goods, services and primary income) of Serbia in 2009 to that in 2011?
Keep it short and to the point. 1.41. What is the ratio of the Stocks(% of exports of goods, services and primary income) in Tunisia in 2009 to that in 2011?
Your answer should be compact. 1.14. What is the ratio of the Stocks(% of exports of goods, services and primary income) in Georgia in 2009 to that in 2012?
Your response must be concise. 1.35. What is the ratio of the Stocks(% of exports of goods, services and primary income) in Serbia in 2009 to that in 2012?
Ensure brevity in your answer.  1.22. What is the ratio of the Stocks(% of exports of goods, services and primary income) of Tunisia in 2009 to that in 2012?
Offer a very short reply. 1.01. What is the ratio of the Stocks(% of exports of goods, services and primary income) of Georgia in 2009 to that in 2013?
Ensure brevity in your answer.  1.39. What is the ratio of the Stocks(% of exports of goods, services and primary income) in Serbia in 2009 to that in 2013?
Your answer should be compact. 1.44. What is the ratio of the Stocks(% of exports of goods, services and primary income) of Tunisia in 2009 to that in 2013?
Your answer should be compact. 0.99. What is the ratio of the Stocks(% of exports of goods, services and primary income) in Georgia in 2009 to that in 2014?
Your response must be concise. 1.36. What is the ratio of the Stocks(% of exports of goods, services and primary income) in Serbia in 2009 to that in 2014?
Your response must be concise. 1.63. What is the ratio of the Stocks(% of exports of goods, services and primary income) in Tunisia in 2009 to that in 2014?
Offer a terse response. 0.94. What is the ratio of the Stocks(% of exports of goods, services and primary income) in Georgia in 2010 to that in 2011?
Make the answer very short. 1.11. What is the ratio of the Stocks(% of exports of goods, services and primary income) in Serbia in 2010 to that in 2011?
Make the answer very short. 1.24. What is the ratio of the Stocks(% of exports of goods, services and primary income) of Tunisia in 2010 to that in 2011?
Your answer should be very brief. 1.01. What is the ratio of the Stocks(% of exports of goods, services and primary income) of Georgia in 2010 to that in 2012?
Keep it short and to the point. 1.21. What is the ratio of the Stocks(% of exports of goods, services and primary income) of Serbia in 2010 to that in 2012?
Provide a succinct answer. 1.07. What is the ratio of the Stocks(% of exports of goods, services and primary income) of Tunisia in 2010 to that in 2012?
Give a very brief answer. 0.89. What is the ratio of the Stocks(% of exports of goods, services and primary income) in Georgia in 2010 to that in 2013?
Ensure brevity in your answer.  1.24. What is the ratio of the Stocks(% of exports of goods, services and primary income) in Serbia in 2010 to that in 2013?
Provide a succinct answer. 1.26. What is the ratio of the Stocks(% of exports of goods, services and primary income) in Tunisia in 2010 to that in 2013?
Provide a succinct answer. 0.87. What is the ratio of the Stocks(% of exports of goods, services and primary income) of Georgia in 2010 to that in 2014?
Keep it short and to the point. 1.21. What is the ratio of the Stocks(% of exports of goods, services and primary income) of Serbia in 2010 to that in 2014?
Make the answer very short. 1.43. What is the ratio of the Stocks(% of exports of goods, services and primary income) in Tunisia in 2010 to that in 2014?
Provide a short and direct response. 0.83. What is the ratio of the Stocks(% of exports of goods, services and primary income) of Georgia in 2011 to that in 2012?
Offer a terse response. 1.09. What is the ratio of the Stocks(% of exports of goods, services and primary income) in Serbia in 2011 to that in 2012?
Provide a succinct answer. 0.87. What is the ratio of the Stocks(% of exports of goods, services and primary income) in Tunisia in 2011 to that in 2012?
Offer a terse response. 0.88. What is the ratio of the Stocks(% of exports of goods, services and primary income) in Georgia in 2011 to that in 2013?
Provide a short and direct response. 1.12. What is the ratio of the Stocks(% of exports of goods, services and primary income) in Serbia in 2011 to that in 2013?
Provide a short and direct response. 1.02. What is the ratio of the Stocks(% of exports of goods, services and primary income) of Tunisia in 2011 to that in 2013?
Offer a terse response. 0.87. What is the ratio of the Stocks(% of exports of goods, services and primary income) in Georgia in 2011 to that in 2014?
Make the answer very short. 1.09. What is the ratio of the Stocks(% of exports of goods, services and primary income) of Serbia in 2011 to that in 2014?
Keep it short and to the point. 1.16. What is the ratio of the Stocks(% of exports of goods, services and primary income) in Tunisia in 2011 to that in 2014?
Provide a short and direct response. 0.83. What is the ratio of the Stocks(% of exports of goods, services and primary income) in Georgia in 2012 to that in 2013?
Your answer should be compact. 1.03. What is the ratio of the Stocks(% of exports of goods, services and primary income) of Serbia in 2012 to that in 2013?
Ensure brevity in your answer.  1.17. What is the ratio of the Stocks(% of exports of goods, services and primary income) of Tunisia in 2012 to that in 2013?
Offer a terse response. 0.98. What is the ratio of the Stocks(% of exports of goods, services and primary income) in Georgia in 2012 to that in 2014?
Your answer should be very brief. 1.01. What is the ratio of the Stocks(% of exports of goods, services and primary income) of Serbia in 2012 to that in 2014?
Your response must be concise. 1.34. What is the ratio of the Stocks(% of exports of goods, services and primary income) in Tunisia in 2012 to that in 2014?
Offer a terse response. 0.94. What is the ratio of the Stocks(% of exports of goods, services and primary income) of Serbia in 2013 to that in 2014?
Offer a terse response. 1.14. What is the ratio of the Stocks(% of exports of goods, services and primary income) in Tunisia in 2013 to that in 2014?
Your answer should be very brief. 0.95. What is the difference between the highest and the second highest Stocks(% of exports of goods, services and primary income) in Georgia?
Your answer should be compact. 25.82. What is the difference between the highest and the second highest Stocks(% of exports of goods, services and primary income) in Serbia?
Offer a terse response. 32.89. What is the difference between the highest and the second highest Stocks(% of exports of goods, services and primary income) of Tunisia?
Your answer should be very brief. 5.48. What is the difference between the highest and the lowest Stocks(% of exports of goods, services and primary income) in Georgia?
Offer a terse response. 154.23. What is the difference between the highest and the lowest Stocks(% of exports of goods, services and primary income) in Serbia?
Your answer should be very brief. 104.46. What is the difference between the highest and the lowest Stocks(% of exports of goods, services and primary income) of Tunisia?
Make the answer very short. 35.95. 